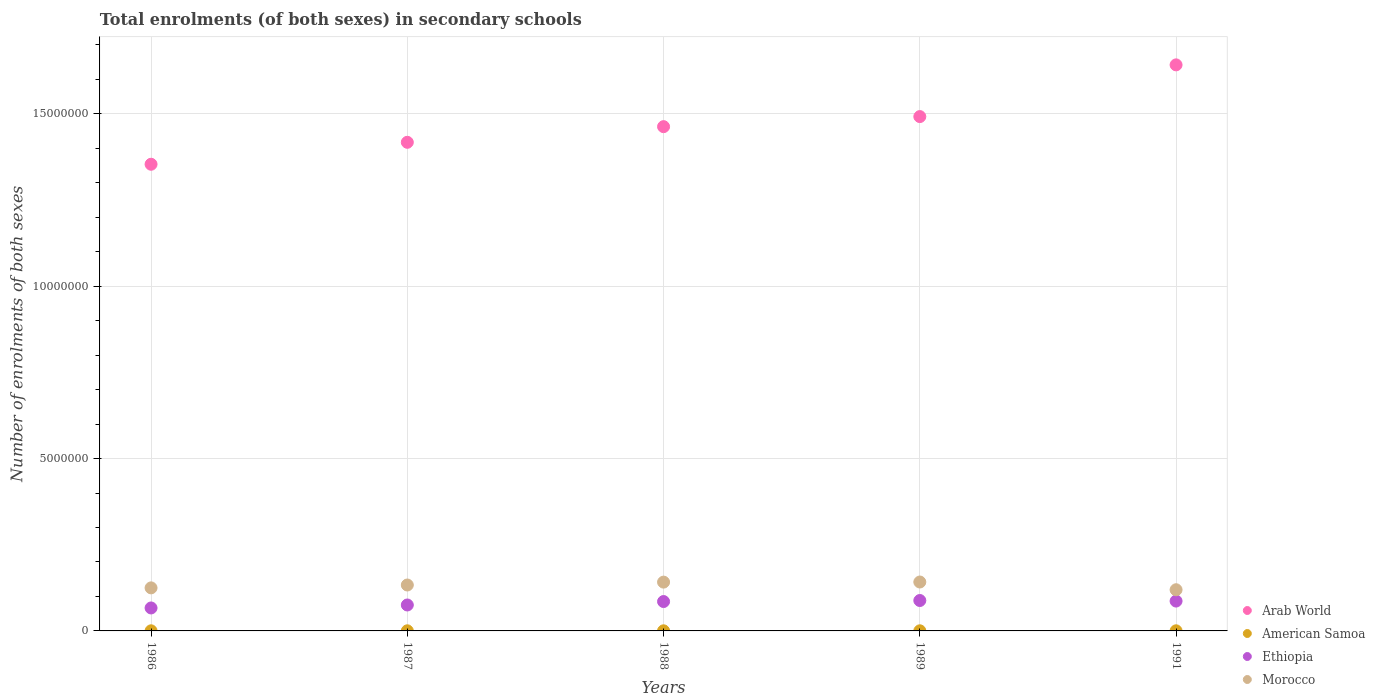What is the number of enrolments in secondary schools in Arab World in 1986?
Provide a succinct answer. 1.35e+07. Across all years, what is the maximum number of enrolments in secondary schools in American Samoa?
Offer a terse response. 3565. Across all years, what is the minimum number of enrolments in secondary schools in Morocco?
Provide a short and direct response. 1.19e+06. In which year was the number of enrolments in secondary schools in Arab World maximum?
Your response must be concise. 1991. In which year was the number of enrolments in secondary schools in Arab World minimum?
Your answer should be compact. 1986. What is the total number of enrolments in secondary schools in Arab World in the graph?
Ensure brevity in your answer.  7.37e+07. What is the difference between the number of enrolments in secondary schools in American Samoa in 1987 and that in 1989?
Keep it short and to the point. -40. What is the difference between the number of enrolments in secondary schools in Ethiopia in 1989 and the number of enrolments in secondary schools in Arab World in 1987?
Offer a terse response. -1.33e+07. What is the average number of enrolments in secondary schools in Arab World per year?
Give a very brief answer. 1.47e+07. In the year 1988, what is the difference between the number of enrolments in secondary schools in American Samoa and number of enrolments in secondary schools in Ethiopia?
Make the answer very short. -8.49e+05. In how many years, is the number of enrolments in secondary schools in Ethiopia greater than 10000000?
Your answer should be compact. 0. What is the ratio of the number of enrolments in secondary schools in Morocco in 1986 to that in 1989?
Your response must be concise. 0.88. Is the number of enrolments in secondary schools in Morocco in 1987 less than that in 1991?
Make the answer very short. No. What is the difference between the highest and the second highest number of enrolments in secondary schools in Ethiopia?
Ensure brevity in your answer.  1.61e+04. What is the difference between the highest and the lowest number of enrolments in secondary schools in Arab World?
Your answer should be very brief. 2.88e+06. In how many years, is the number of enrolments in secondary schools in Arab World greater than the average number of enrolments in secondary schools in Arab World taken over all years?
Provide a short and direct response. 2. Is the sum of the number of enrolments in secondary schools in Morocco in 1987 and 1989 greater than the maximum number of enrolments in secondary schools in American Samoa across all years?
Give a very brief answer. Yes. Does the number of enrolments in secondary schools in Ethiopia monotonically increase over the years?
Ensure brevity in your answer.  No. How many dotlines are there?
Your response must be concise. 4. How many years are there in the graph?
Give a very brief answer. 5. What is the difference between two consecutive major ticks on the Y-axis?
Make the answer very short. 5.00e+06. Are the values on the major ticks of Y-axis written in scientific E-notation?
Ensure brevity in your answer.  No. Does the graph contain any zero values?
Keep it short and to the point. No. Does the graph contain grids?
Your answer should be compact. Yes. Where does the legend appear in the graph?
Your response must be concise. Bottom right. How many legend labels are there?
Your answer should be very brief. 4. How are the legend labels stacked?
Provide a succinct answer. Vertical. What is the title of the graph?
Ensure brevity in your answer.  Total enrolments (of both sexes) in secondary schools. What is the label or title of the X-axis?
Offer a terse response. Years. What is the label or title of the Y-axis?
Ensure brevity in your answer.  Number of enrolments of both sexes. What is the Number of enrolments of both sexes in Arab World in 1986?
Provide a short and direct response. 1.35e+07. What is the Number of enrolments of both sexes of American Samoa in 1986?
Keep it short and to the point. 3342. What is the Number of enrolments of both sexes in Ethiopia in 1986?
Provide a short and direct response. 6.66e+05. What is the Number of enrolments of both sexes in Morocco in 1986?
Your answer should be very brief. 1.25e+06. What is the Number of enrolments of both sexes of Arab World in 1987?
Make the answer very short. 1.42e+07. What is the Number of enrolments of both sexes in American Samoa in 1987?
Your answer should be compact. 3295. What is the Number of enrolments of both sexes of Ethiopia in 1987?
Keep it short and to the point. 7.52e+05. What is the Number of enrolments of both sexes of Morocco in 1987?
Provide a succinct answer. 1.33e+06. What is the Number of enrolments of both sexes of Arab World in 1988?
Your answer should be very brief. 1.46e+07. What is the Number of enrolments of both sexes of American Samoa in 1988?
Offer a very short reply. 3210. What is the Number of enrolments of both sexes of Ethiopia in 1988?
Make the answer very short. 8.52e+05. What is the Number of enrolments of both sexes of Morocco in 1988?
Provide a short and direct response. 1.42e+06. What is the Number of enrolments of both sexes of Arab World in 1989?
Offer a terse response. 1.49e+07. What is the Number of enrolments of both sexes of American Samoa in 1989?
Your answer should be compact. 3335. What is the Number of enrolments of both sexes in Ethiopia in 1989?
Offer a terse response. 8.82e+05. What is the Number of enrolments of both sexes in Morocco in 1989?
Make the answer very short. 1.42e+06. What is the Number of enrolments of both sexes of Arab World in 1991?
Offer a terse response. 1.64e+07. What is the Number of enrolments of both sexes in American Samoa in 1991?
Provide a short and direct response. 3565. What is the Number of enrolments of both sexes of Ethiopia in 1991?
Make the answer very short. 8.66e+05. What is the Number of enrolments of both sexes in Morocco in 1991?
Your answer should be compact. 1.19e+06. Across all years, what is the maximum Number of enrolments of both sexes in Arab World?
Your answer should be compact. 1.64e+07. Across all years, what is the maximum Number of enrolments of both sexes in American Samoa?
Make the answer very short. 3565. Across all years, what is the maximum Number of enrolments of both sexes in Ethiopia?
Ensure brevity in your answer.  8.82e+05. Across all years, what is the maximum Number of enrolments of both sexes in Morocco?
Provide a short and direct response. 1.42e+06. Across all years, what is the minimum Number of enrolments of both sexes in Arab World?
Provide a short and direct response. 1.35e+07. Across all years, what is the minimum Number of enrolments of both sexes of American Samoa?
Offer a terse response. 3210. Across all years, what is the minimum Number of enrolments of both sexes in Ethiopia?
Ensure brevity in your answer.  6.66e+05. Across all years, what is the minimum Number of enrolments of both sexes in Morocco?
Your answer should be very brief. 1.19e+06. What is the total Number of enrolments of both sexes in Arab World in the graph?
Keep it short and to the point. 7.37e+07. What is the total Number of enrolments of both sexes in American Samoa in the graph?
Ensure brevity in your answer.  1.67e+04. What is the total Number of enrolments of both sexes of Ethiopia in the graph?
Your response must be concise. 4.02e+06. What is the total Number of enrolments of both sexes of Morocco in the graph?
Provide a short and direct response. 6.61e+06. What is the difference between the Number of enrolments of both sexes in Arab World in 1986 and that in 1987?
Provide a succinct answer. -6.37e+05. What is the difference between the Number of enrolments of both sexes in American Samoa in 1986 and that in 1987?
Your response must be concise. 47. What is the difference between the Number of enrolments of both sexes of Ethiopia in 1986 and that in 1987?
Ensure brevity in your answer.  -8.62e+04. What is the difference between the Number of enrolments of both sexes in Morocco in 1986 and that in 1987?
Offer a terse response. -8.33e+04. What is the difference between the Number of enrolments of both sexes in Arab World in 1986 and that in 1988?
Your response must be concise. -1.09e+06. What is the difference between the Number of enrolments of both sexes of American Samoa in 1986 and that in 1988?
Provide a succinct answer. 132. What is the difference between the Number of enrolments of both sexes in Ethiopia in 1986 and that in 1988?
Offer a very short reply. -1.86e+05. What is the difference between the Number of enrolments of both sexes in Morocco in 1986 and that in 1988?
Offer a very short reply. -1.67e+05. What is the difference between the Number of enrolments of both sexes in Arab World in 1986 and that in 1989?
Your answer should be compact. -1.38e+06. What is the difference between the Number of enrolments of both sexes of Ethiopia in 1986 and that in 1989?
Your answer should be compact. -2.16e+05. What is the difference between the Number of enrolments of both sexes in Morocco in 1986 and that in 1989?
Offer a very short reply. -1.70e+05. What is the difference between the Number of enrolments of both sexes in Arab World in 1986 and that in 1991?
Your response must be concise. -2.88e+06. What is the difference between the Number of enrolments of both sexes of American Samoa in 1986 and that in 1991?
Your answer should be compact. -223. What is the difference between the Number of enrolments of both sexes of Ethiopia in 1986 and that in 1991?
Make the answer very short. -2.00e+05. What is the difference between the Number of enrolments of both sexes in Morocco in 1986 and that in 1991?
Keep it short and to the point. 5.43e+04. What is the difference between the Number of enrolments of both sexes of Arab World in 1987 and that in 1988?
Your answer should be compact. -4.54e+05. What is the difference between the Number of enrolments of both sexes of American Samoa in 1987 and that in 1988?
Give a very brief answer. 85. What is the difference between the Number of enrolments of both sexes in Ethiopia in 1987 and that in 1988?
Give a very brief answer. -9.99e+04. What is the difference between the Number of enrolments of both sexes in Morocco in 1987 and that in 1988?
Your response must be concise. -8.36e+04. What is the difference between the Number of enrolments of both sexes in Arab World in 1987 and that in 1989?
Ensure brevity in your answer.  -7.46e+05. What is the difference between the Number of enrolments of both sexes of Ethiopia in 1987 and that in 1989?
Your response must be concise. -1.30e+05. What is the difference between the Number of enrolments of both sexes in Morocco in 1987 and that in 1989?
Your answer should be compact. -8.68e+04. What is the difference between the Number of enrolments of both sexes of Arab World in 1987 and that in 1991?
Make the answer very short. -2.25e+06. What is the difference between the Number of enrolments of both sexes in American Samoa in 1987 and that in 1991?
Offer a very short reply. -270. What is the difference between the Number of enrolments of both sexes of Ethiopia in 1987 and that in 1991?
Give a very brief answer. -1.14e+05. What is the difference between the Number of enrolments of both sexes in Morocco in 1987 and that in 1991?
Provide a succinct answer. 1.38e+05. What is the difference between the Number of enrolments of both sexes of Arab World in 1988 and that in 1989?
Make the answer very short. -2.92e+05. What is the difference between the Number of enrolments of both sexes of American Samoa in 1988 and that in 1989?
Provide a short and direct response. -125. What is the difference between the Number of enrolments of both sexes of Ethiopia in 1988 and that in 1989?
Provide a succinct answer. -2.99e+04. What is the difference between the Number of enrolments of both sexes of Morocco in 1988 and that in 1989?
Ensure brevity in your answer.  -3282. What is the difference between the Number of enrolments of both sexes in Arab World in 1988 and that in 1991?
Offer a very short reply. -1.79e+06. What is the difference between the Number of enrolments of both sexes in American Samoa in 1988 and that in 1991?
Provide a succinct answer. -355. What is the difference between the Number of enrolments of both sexes of Ethiopia in 1988 and that in 1991?
Keep it short and to the point. -1.38e+04. What is the difference between the Number of enrolments of both sexes in Morocco in 1988 and that in 1991?
Make the answer very short. 2.21e+05. What is the difference between the Number of enrolments of both sexes in Arab World in 1989 and that in 1991?
Offer a terse response. -1.50e+06. What is the difference between the Number of enrolments of both sexes in American Samoa in 1989 and that in 1991?
Ensure brevity in your answer.  -230. What is the difference between the Number of enrolments of both sexes in Ethiopia in 1989 and that in 1991?
Give a very brief answer. 1.61e+04. What is the difference between the Number of enrolments of both sexes of Morocco in 1989 and that in 1991?
Give a very brief answer. 2.24e+05. What is the difference between the Number of enrolments of both sexes of Arab World in 1986 and the Number of enrolments of both sexes of American Samoa in 1987?
Your answer should be compact. 1.35e+07. What is the difference between the Number of enrolments of both sexes in Arab World in 1986 and the Number of enrolments of both sexes in Ethiopia in 1987?
Your response must be concise. 1.28e+07. What is the difference between the Number of enrolments of both sexes of Arab World in 1986 and the Number of enrolments of both sexes of Morocco in 1987?
Provide a short and direct response. 1.22e+07. What is the difference between the Number of enrolments of both sexes in American Samoa in 1986 and the Number of enrolments of both sexes in Ethiopia in 1987?
Your answer should be very brief. -7.49e+05. What is the difference between the Number of enrolments of both sexes of American Samoa in 1986 and the Number of enrolments of both sexes of Morocco in 1987?
Make the answer very short. -1.33e+06. What is the difference between the Number of enrolments of both sexes in Ethiopia in 1986 and the Number of enrolments of both sexes in Morocco in 1987?
Ensure brevity in your answer.  -6.66e+05. What is the difference between the Number of enrolments of both sexes in Arab World in 1986 and the Number of enrolments of both sexes in American Samoa in 1988?
Offer a terse response. 1.35e+07. What is the difference between the Number of enrolments of both sexes in Arab World in 1986 and the Number of enrolments of both sexes in Ethiopia in 1988?
Offer a very short reply. 1.27e+07. What is the difference between the Number of enrolments of both sexes of Arab World in 1986 and the Number of enrolments of both sexes of Morocco in 1988?
Offer a terse response. 1.21e+07. What is the difference between the Number of enrolments of both sexes in American Samoa in 1986 and the Number of enrolments of both sexes in Ethiopia in 1988?
Your answer should be compact. -8.49e+05. What is the difference between the Number of enrolments of both sexes in American Samoa in 1986 and the Number of enrolments of both sexes in Morocco in 1988?
Ensure brevity in your answer.  -1.41e+06. What is the difference between the Number of enrolments of both sexes of Ethiopia in 1986 and the Number of enrolments of both sexes of Morocco in 1988?
Ensure brevity in your answer.  -7.49e+05. What is the difference between the Number of enrolments of both sexes of Arab World in 1986 and the Number of enrolments of both sexes of American Samoa in 1989?
Your answer should be compact. 1.35e+07. What is the difference between the Number of enrolments of both sexes of Arab World in 1986 and the Number of enrolments of both sexes of Ethiopia in 1989?
Provide a short and direct response. 1.27e+07. What is the difference between the Number of enrolments of both sexes of Arab World in 1986 and the Number of enrolments of both sexes of Morocco in 1989?
Ensure brevity in your answer.  1.21e+07. What is the difference between the Number of enrolments of both sexes of American Samoa in 1986 and the Number of enrolments of both sexes of Ethiopia in 1989?
Provide a succinct answer. -8.79e+05. What is the difference between the Number of enrolments of both sexes of American Samoa in 1986 and the Number of enrolments of both sexes of Morocco in 1989?
Give a very brief answer. -1.42e+06. What is the difference between the Number of enrolments of both sexes of Ethiopia in 1986 and the Number of enrolments of both sexes of Morocco in 1989?
Your response must be concise. -7.53e+05. What is the difference between the Number of enrolments of both sexes in Arab World in 1986 and the Number of enrolments of both sexes in American Samoa in 1991?
Give a very brief answer. 1.35e+07. What is the difference between the Number of enrolments of both sexes of Arab World in 1986 and the Number of enrolments of both sexes of Ethiopia in 1991?
Give a very brief answer. 1.27e+07. What is the difference between the Number of enrolments of both sexes in Arab World in 1986 and the Number of enrolments of both sexes in Morocco in 1991?
Provide a short and direct response. 1.23e+07. What is the difference between the Number of enrolments of both sexes of American Samoa in 1986 and the Number of enrolments of both sexes of Ethiopia in 1991?
Ensure brevity in your answer.  -8.63e+05. What is the difference between the Number of enrolments of both sexes of American Samoa in 1986 and the Number of enrolments of both sexes of Morocco in 1991?
Your answer should be very brief. -1.19e+06. What is the difference between the Number of enrolments of both sexes in Ethiopia in 1986 and the Number of enrolments of both sexes in Morocco in 1991?
Provide a short and direct response. -5.28e+05. What is the difference between the Number of enrolments of both sexes of Arab World in 1987 and the Number of enrolments of both sexes of American Samoa in 1988?
Ensure brevity in your answer.  1.42e+07. What is the difference between the Number of enrolments of both sexes in Arab World in 1987 and the Number of enrolments of both sexes in Ethiopia in 1988?
Make the answer very short. 1.33e+07. What is the difference between the Number of enrolments of both sexes in Arab World in 1987 and the Number of enrolments of both sexes in Morocco in 1988?
Ensure brevity in your answer.  1.28e+07. What is the difference between the Number of enrolments of both sexes of American Samoa in 1987 and the Number of enrolments of both sexes of Ethiopia in 1988?
Ensure brevity in your answer.  -8.49e+05. What is the difference between the Number of enrolments of both sexes of American Samoa in 1987 and the Number of enrolments of both sexes of Morocco in 1988?
Offer a very short reply. -1.41e+06. What is the difference between the Number of enrolments of both sexes in Ethiopia in 1987 and the Number of enrolments of both sexes in Morocco in 1988?
Your answer should be compact. -6.63e+05. What is the difference between the Number of enrolments of both sexes of Arab World in 1987 and the Number of enrolments of both sexes of American Samoa in 1989?
Make the answer very short. 1.42e+07. What is the difference between the Number of enrolments of both sexes of Arab World in 1987 and the Number of enrolments of both sexes of Ethiopia in 1989?
Offer a terse response. 1.33e+07. What is the difference between the Number of enrolments of both sexes of Arab World in 1987 and the Number of enrolments of both sexes of Morocco in 1989?
Ensure brevity in your answer.  1.28e+07. What is the difference between the Number of enrolments of both sexes in American Samoa in 1987 and the Number of enrolments of both sexes in Ethiopia in 1989?
Your answer should be compact. -8.79e+05. What is the difference between the Number of enrolments of both sexes in American Samoa in 1987 and the Number of enrolments of both sexes in Morocco in 1989?
Your answer should be very brief. -1.42e+06. What is the difference between the Number of enrolments of both sexes of Ethiopia in 1987 and the Number of enrolments of both sexes of Morocco in 1989?
Ensure brevity in your answer.  -6.66e+05. What is the difference between the Number of enrolments of both sexes of Arab World in 1987 and the Number of enrolments of both sexes of American Samoa in 1991?
Ensure brevity in your answer.  1.42e+07. What is the difference between the Number of enrolments of both sexes in Arab World in 1987 and the Number of enrolments of both sexes in Ethiopia in 1991?
Offer a very short reply. 1.33e+07. What is the difference between the Number of enrolments of both sexes in Arab World in 1987 and the Number of enrolments of both sexes in Morocco in 1991?
Keep it short and to the point. 1.30e+07. What is the difference between the Number of enrolments of both sexes in American Samoa in 1987 and the Number of enrolments of both sexes in Ethiopia in 1991?
Ensure brevity in your answer.  -8.63e+05. What is the difference between the Number of enrolments of both sexes in American Samoa in 1987 and the Number of enrolments of both sexes in Morocco in 1991?
Keep it short and to the point. -1.19e+06. What is the difference between the Number of enrolments of both sexes in Ethiopia in 1987 and the Number of enrolments of both sexes in Morocco in 1991?
Provide a short and direct response. -4.42e+05. What is the difference between the Number of enrolments of both sexes of Arab World in 1988 and the Number of enrolments of both sexes of American Samoa in 1989?
Ensure brevity in your answer.  1.46e+07. What is the difference between the Number of enrolments of both sexes in Arab World in 1988 and the Number of enrolments of both sexes in Ethiopia in 1989?
Provide a succinct answer. 1.37e+07. What is the difference between the Number of enrolments of both sexes in Arab World in 1988 and the Number of enrolments of both sexes in Morocco in 1989?
Your answer should be compact. 1.32e+07. What is the difference between the Number of enrolments of both sexes of American Samoa in 1988 and the Number of enrolments of both sexes of Ethiopia in 1989?
Offer a terse response. -8.79e+05. What is the difference between the Number of enrolments of both sexes of American Samoa in 1988 and the Number of enrolments of both sexes of Morocco in 1989?
Ensure brevity in your answer.  -1.42e+06. What is the difference between the Number of enrolments of both sexes of Ethiopia in 1988 and the Number of enrolments of both sexes of Morocco in 1989?
Keep it short and to the point. -5.67e+05. What is the difference between the Number of enrolments of both sexes in Arab World in 1988 and the Number of enrolments of both sexes in American Samoa in 1991?
Provide a short and direct response. 1.46e+07. What is the difference between the Number of enrolments of both sexes in Arab World in 1988 and the Number of enrolments of both sexes in Ethiopia in 1991?
Offer a terse response. 1.38e+07. What is the difference between the Number of enrolments of both sexes of Arab World in 1988 and the Number of enrolments of both sexes of Morocco in 1991?
Offer a very short reply. 1.34e+07. What is the difference between the Number of enrolments of both sexes of American Samoa in 1988 and the Number of enrolments of both sexes of Ethiopia in 1991?
Offer a very short reply. -8.63e+05. What is the difference between the Number of enrolments of both sexes in American Samoa in 1988 and the Number of enrolments of both sexes in Morocco in 1991?
Offer a terse response. -1.19e+06. What is the difference between the Number of enrolments of both sexes in Ethiopia in 1988 and the Number of enrolments of both sexes in Morocco in 1991?
Ensure brevity in your answer.  -3.42e+05. What is the difference between the Number of enrolments of both sexes of Arab World in 1989 and the Number of enrolments of both sexes of American Samoa in 1991?
Your response must be concise. 1.49e+07. What is the difference between the Number of enrolments of both sexes in Arab World in 1989 and the Number of enrolments of both sexes in Ethiopia in 1991?
Make the answer very short. 1.41e+07. What is the difference between the Number of enrolments of both sexes of Arab World in 1989 and the Number of enrolments of both sexes of Morocco in 1991?
Provide a succinct answer. 1.37e+07. What is the difference between the Number of enrolments of both sexes in American Samoa in 1989 and the Number of enrolments of both sexes in Ethiopia in 1991?
Offer a terse response. -8.63e+05. What is the difference between the Number of enrolments of both sexes of American Samoa in 1989 and the Number of enrolments of both sexes of Morocco in 1991?
Offer a terse response. -1.19e+06. What is the difference between the Number of enrolments of both sexes in Ethiopia in 1989 and the Number of enrolments of both sexes in Morocco in 1991?
Make the answer very short. -3.12e+05. What is the average Number of enrolments of both sexes of Arab World per year?
Ensure brevity in your answer.  1.47e+07. What is the average Number of enrolments of both sexes in American Samoa per year?
Offer a very short reply. 3349.4. What is the average Number of enrolments of both sexes of Ethiopia per year?
Offer a very short reply. 8.04e+05. What is the average Number of enrolments of both sexes of Morocco per year?
Your answer should be compact. 1.32e+06. In the year 1986, what is the difference between the Number of enrolments of both sexes in Arab World and Number of enrolments of both sexes in American Samoa?
Your answer should be very brief. 1.35e+07. In the year 1986, what is the difference between the Number of enrolments of both sexes of Arab World and Number of enrolments of both sexes of Ethiopia?
Ensure brevity in your answer.  1.29e+07. In the year 1986, what is the difference between the Number of enrolments of both sexes in Arab World and Number of enrolments of both sexes in Morocco?
Keep it short and to the point. 1.23e+07. In the year 1986, what is the difference between the Number of enrolments of both sexes in American Samoa and Number of enrolments of both sexes in Ethiopia?
Make the answer very short. -6.63e+05. In the year 1986, what is the difference between the Number of enrolments of both sexes of American Samoa and Number of enrolments of both sexes of Morocco?
Make the answer very short. -1.25e+06. In the year 1986, what is the difference between the Number of enrolments of both sexes in Ethiopia and Number of enrolments of both sexes in Morocco?
Give a very brief answer. -5.83e+05. In the year 1987, what is the difference between the Number of enrolments of both sexes in Arab World and Number of enrolments of both sexes in American Samoa?
Your answer should be compact. 1.42e+07. In the year 1987, what is the difference between the Number of enrolments of both sexes in Arab World and Number of enrolments of both sexes in Ethiopia?
Ensure brevity in your answer.  1.34e+07. In the year 1987, what is the difference between the Number of enrolments of both sexes in Arab World and Number of enrolments of both sexes in Morocco?
Your answer should be compact. 1.28e+07. In the year 1987, what is the difference between the Number of enrolments of both sexes of American Samoa and Number of enrolments of both sexes of Ethiopia?
Provide a succinct answer. -7.49e+05. In the year 1987, what is the difference between the Number of enrolments of both sexes of American Samoa and Number of enrolments of both sexes of Morocco?
Your answer should be very brief. -1.33e+06. In the year 1987, what is the difference between the Number of enrolments of both sexes in Ethiopia and Number of enrolments of both sexes in Morocco?
Offer a terse response. -5.80e+05. In the year 1988, what is the difference between the Number of enrolments of both sexes in Arab World and Number of enrolments of both sexes in American Samoa?
Your answer should be very brief. 1.46e+07. In the year 1988, what is the difference between the Number of enrolments of both sexes in Arab World and Number of enrolments of both sexes in Ethiopia?
Provide a short and direct response. 1.38e+07. In the year 1988, what is the difference between the Number of enrolments of both sexes of Arab World and Number of enrolments of both sexes of Morocco?
Your response must be concise. 1.32e+07. In the year 1988, what is the difference between the Number of enrolments of both sexes in American Samoa and Number of enrolments of both sexes in Ethiopia?
Your response must be concise. -8.49e+05. In the year 1988, what is the difference between the Number of enrolments of both sexes in American Samoa and Number of enrolments of both sexes in Morocco?
Ensure brevity in your answer.  -1.41e+06. In the year 1988, what is the difference between the Number of enrolments of both sexes in Ethiopia and Number of enrolments of both sexes in Morocco?
Give a very brief answer. -5.63e+05. In the year 1989, what is the difference between the Number of enrolments of both sexes in Arab World and Number of enrolments of both sexes in American Samoa?
Your answer should be very brief. 1.49e+07. In the year 1989, what is the difference between the Number of enrolments of both sexes in Arab World and Number of enrolments of both sexes in Ethiopia?
Give a very brief answer. 1.40e+07. In the year 1989, what is the difference between the Number of enrolments of both sexes of Arab World and Number of enrolments of both sexes of Morocco?
Offer a very short reply. 1.35e+07. In the year 1989, what is the difference between the Number of enrolments of both sexes in American Samoa and Number of enrolments of both sexes in Ethiopia?
Your answer should be very brief. -8.79e+05. In the year 1989, what is the difference between the Number of enrolments of both sexes of American Samoa and Number of enrolments of both sexes of Morocco?
Ensure brevity in your answer.  -1.42e+06. In the year 1989, what is the difference between the Number of enrolments of both sexes of Ethiopia and Number of enrolments of both sexes of Morocco?
Provide a short and direct response. -5.37e+05. In the year 1991, what is the difference between the Number of enrolments of both sexes in Arab World and Number of enrolments of both sexes in American Samoa?
Make the answer very short. 1.64e+07. In the year 1991, what is the difference between the Number of enrolments of both sexes of Arab World and Number of enrolments of both sexes of Ethiopia?
Your answer should be very brief. 1.56e+07. In the year 1991, what is the difference between the Number of enrolments of both sexes of Arab World and Number of enrolments of both sexes of Morocco?
Provide a short and direct response. 1.52e+07. In the year 1991, what is the difference between the Number of enrolments of both sexes of American Samoa and Number of enrolments of both sexes of Ethiopia?
Give a very brief answer. -8.62e+05. In the year 1991, what is the difference between the Number of enrolments of both sexes in American Samoa and Number of enrolments of both sexes in Morocco?
Provide a short and direct response. -1.19e+06. In the year 1991, what is the difference between the Number of enrolments of both sexes in Ethiopia and Number of enrolments of both sexes in Morocco?
Your answer should be compact. -3.28e+05. What is the ratio of the Number of enrolments of both sexes of Arab World in 1986 to that in 1987?
Your answer should be very brief. 0.96. What is the ratio of the Number of enrolments of both sexes of American Samoa in 1986 to that in 1987?
Offer a very short reply. 1.01. What is the ratio of the Number of enrolments of both sexes of Ethiopia in 1986 to that in 1987?
Your answer should be very brief. 0.89. What is the ratio of the Number of enrolments of both sexes in Arab World in 1986 to that in 1988?
Offer a very short reply. 0.93. What is the ratio of the Number of enrolments of both sexes of American Samoa in 1986 to that in 1988?
Offer a very short reply. 1.04. What is the ratio of the Number of enrolments of both sexes in Ethiopia in 1986 to that in 1988?
Offer a terse response. 0.78. What is the ratio of the Number of enrolments of both sexes of Morocco in 1986 to that in 1988?
Offer a very short reply. 0.88. What is the ratio of the Number of enrolments of both sexes in Arab World in 1986 to that in 1989?
Give a very brief answer. 0.91. What is the ratio of the Number of enrolments of both sexes in Ethiopia in 1986 to that in 1989?
Provide a succinct answer. 0.76. What is the ratio of the Number of enrolments of both sexes of Morocco in 1986 to that in 1989?
Offer a terse response. 0.88. What is the ratio of the Number of enrolments of both sexes in Arab World in 1986 to that in 1991?
Make the answer very short. 0.82. What is the ratio of the Number of enrolments of both sexes of American Samoa in 1986 to that in 1991?
Keep it short and to the point. 0.94. What is the ratio of the Number of enrolments of both sexes in Ethiopia in 1986 to that in 1991?
Your answer should be compact. 0.77. What is the ratio of the Number of enrolments of both sexes in Morocco in 1986 to that in 1991?
Your response must be concise. 1.05. What is the ratio of the Number of enrolments of both sexes in Arab World in 1987 to that in 1988?
Ensure brevity in your answer.  0.97. What is the ratio of the Number of enrolments of both sexes in American Samoa in 1987 to that in 1988?
Give a very brief answer. 1.03. What is the ratio of the Number of enrolments of both sexes in Ethiopia in 1987 to that in 1988?
Your answer should be compact. 0.88. What is the ratio of the Number of enrolments of both sexes of Morocco in 1987 to that in 1988?
Provide a succinct answer. 0.94. What is the ratio of the Number of enrolments of both sexes of American Samoa in 1987 to that in 1989?
Make the answer very short. 0.99. What is the ratio of the Number of enrolments of both sexes in Ethiopia in 1987 to that in 1989?
Offer a terse response. 0.85. What is the ratio of the Number of enrolments of both sexes in Morocco in 1987 to that in 1989?
Provide a succinct answer. 0.94. What is the ratio of the Number of enrolments of both sexes in Arab World in 1987 to that in 1991?
Your answer should be compact. 0.86. What is the ratio of the Number of enrolments of both sexes of American Samoa in 1987 to that in 1991?
Your answer should be compact. 0.92. What is the ratio of the Number of enrolments of both sexes of Ethiopia in 1987 to that in 1991?
Your answer should be compact. 0.87. What is the ratio of the Number of enrolments of both sexes of Morocco in 1987 to that in 1991?
Your answer should be compact. 1.12. What is the ratio of the Number of enrolments of both sexes in Arab World in 1988 to that in 1989?
Your answer should be very brief. 0.98. What is the ratio of the Number of enrolments of both sexes of American Samoa in 1988 to that in 1989?
Provide a succinct answer. 0.96. What is the ratio of the Number of enrolments of both sexes of Ethiopia in 1988 to that in 1989?
Keep it short and to the point. 0.97. What is the ratio of the Number of enrolments of both sexes in Morocco in 1988 to that in 1989?
Offer a terse response. 1. What is the ratio of the Number of enrolments of both sexes in Arab World in 1988 to that in 1991?
Ensure brevity in your answer.  0.89. What is the ratio of the Number of enrolments of both sexes in American Samoa in 1988 to that in 1991?
Provide a succinct answer. 0.9. What is the ratio of the Number of enrolments of both sexes in Ethiopia in 1988 to that in 1991?
Make the answer very short. 0.98. What is the ratio of the Number of enrolments of both sexes of Morocco in 1988 to that in 1991?
Make the answer very short. 1.19. What is the ratio of the Number of enrolments of both sexes of Arab World in 1989 to that in 1991?
Your answer should be very brief. 0.91. What is the ratio of the Number of enrolments of both sexes of American Samoa in 1989 to that in 1991?
Give a very brief answer. 0.94. What is the ratio of the Number of enrolments of both sexes of Ethiopia in 1989 to that in 1991?
Offer a very short reply. 1.02. What is the ratio of the Number of enrolments of both sexes of Morocco in 1989 to that in 1991?
Make the answer very short. 1.19. What is the difference between the highest and the second highest Number of enrolments of both sexes in Arab World?
Give a very brief answer. 1.50e+06. What is the difference between the highest and the second highest Number of enrolments of both sexes in American Samoa?
Make the answer very short. 223. What is the difference between the highest and the second highest Number of enrolments of both sexes in Ethiopia?
Provide a succinct answer. 1.61e+04. What is the difference between the highest and the second highest Number of enrolments of both sexes in Morocco?
Offer a very short reply. 3282. What is the difference between the highest and the lowest Number of enrolments of both sexes of Arab World?
Your answer should be compact. 2.88e+06. What is the difference between the highest and the lowest Number of enrolments of both sexes in American Samoa?
Make the answer very short. 355. What is the difference between the highest and the lowest Number of enrolments of both sexes of Ethiopia?
Make the answer very short. 2.16e+05. What is the difference between the highest and the lowest Number of enrolments of both sexes in Morocco?
Offer a terse response. 2.24e+05. 